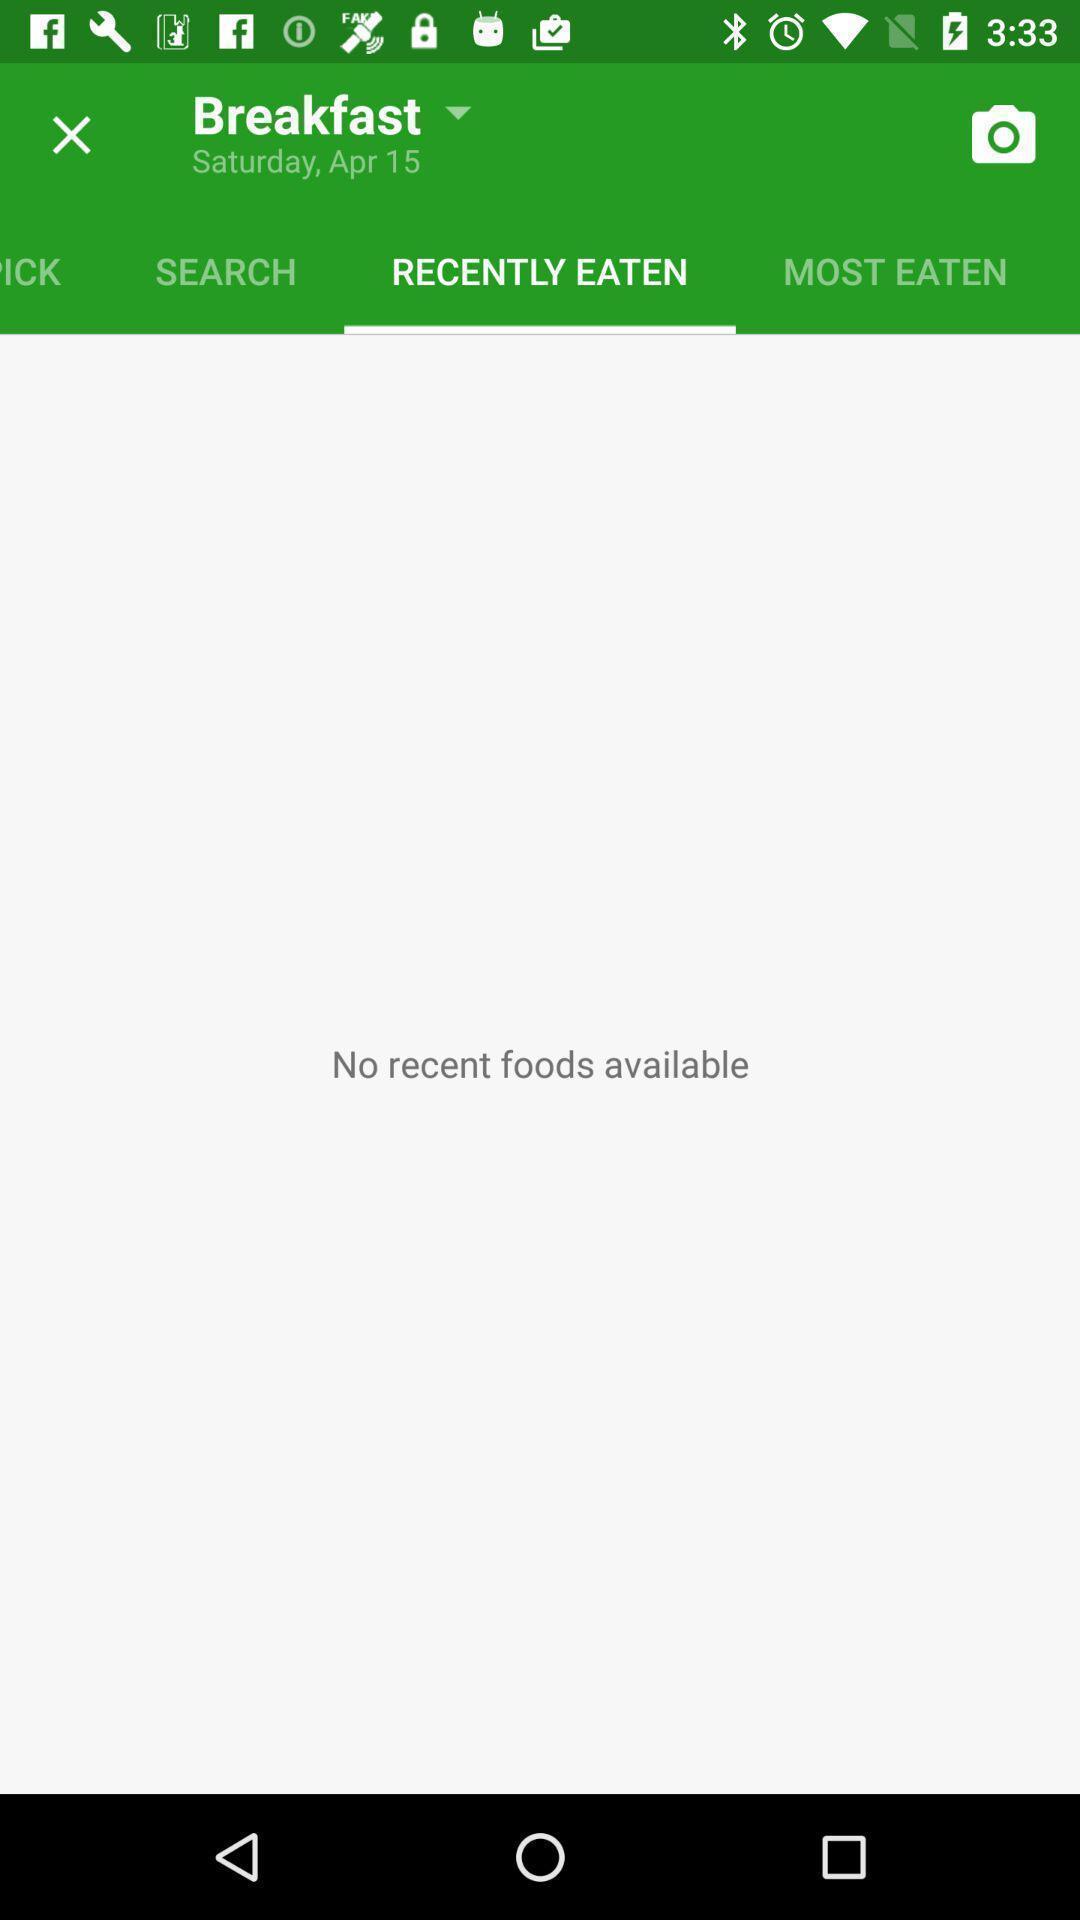Summarize the main components in this picture. Page showing recently eaten food list in the diet app. 